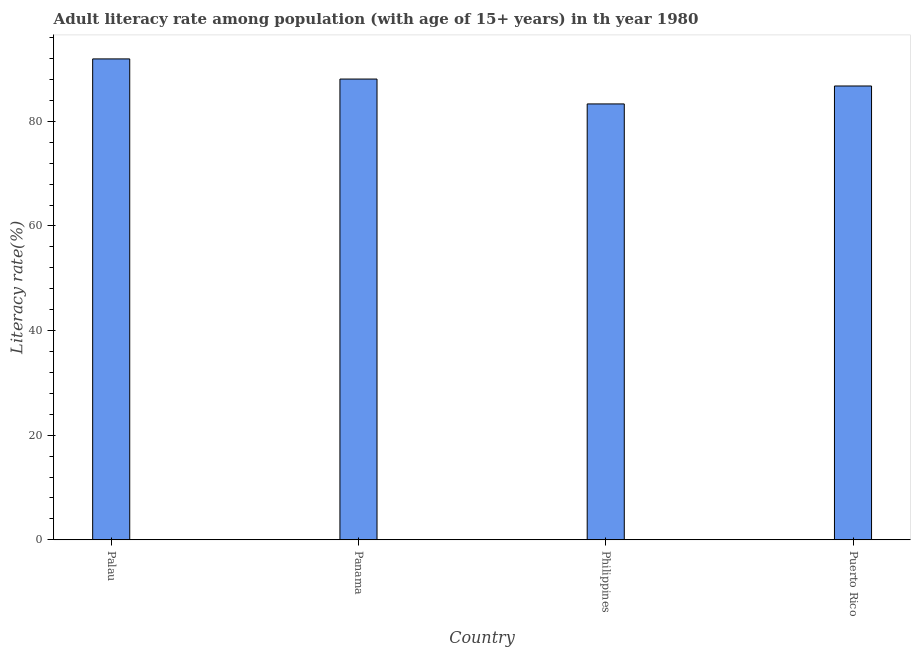Does the graph contain grids?
Offer a terse response. No. What is the title of the graph?
Make the answer very short. Adult literacy rate among population (with age of 15+ years) in th year 1980. What is the label or title of the Y-axis?
Your answer should be very brief. Literacy rate(%). What is the adult literacy rate in Philippines?
Your response must be concise. 83.32. Across all countries, what is the maximum adult literacy rate?
Provide a succinct answer. 91.92. Across all countries, what is the minimum adult literacy rate?
Give a very brief answer. 83.32. In which country was the adult literacy rate maximum?
Ensure brevity in your answer.  Palau. In which country was the adult literacy rate minimum?
Your response must be concise. Philippines. What is the sum of the adult literacy rate?
Your answer should be very brief. 350.06. What is the difference between the adult literacy rate in Palau and Puerto Rico?
Provide a succinct answer. 5.17. What is the average adult literacy rate per country?
Provide a short and direct response. 87.51. What is the median adult literacy rate?
Offer a terse response. 87.41. Is the difference between the adult literacy rate in Palau and Philippines greater than the difference between any two countries?
Your answer should be compact. Yes. What is the difference between the highest and the second highest adult literacy rate?
Make the answer very short. 3.85. Is the sum of the adult literacy rate in Palau and Philippines greater than the maximum adult literacy rate across all countries?
Give a very brief answer. Yes. What is the difference between the highest and the lowest adult literacy rate?
Your answer should be compact. 8.6. How many bars are there?
Provide a succinct answer. 4. Are all the bars in the graph horizontal?
Make the answer very short. No. Are the values on the major ticks of Y-axis written in scientific E-notation?
Your answer should be compact. No. What is the Literacy rate(%) in Palau?
Provide a short and direct response. 91.92. What is the Literacy rate(%) in Panama?
Your answer should be compact. 88.07. What is the Literacy rate(%) of Philippines?
Ensure brevity in your answer.  83.32. What is the Literacy rate(%) in Puerto Rico?
Make the answer very short. 86.75. What is the difference between the Literacy rate(%) in Palau and Panama?
Offer a terse response. 3.85. What is the difference between the Literacy rate(%) in Palau and Philippines?
Keep it short and to the point. 8.6. What is the difference between the Literacy rate(%) in Palau and Puerto Rico?
Ensure brevity in your answer.  5.18. What is the difference between the Literacy rate(%) in Panama and Philippines?
Provide a short and direct response. 4.75. What is the difference between the Literacy rate(%) in Panama and Puerto Rico?
Make the answer very short. 1.33. What is the difference between the Literacy rate(%) in Philippines and Puerto Rico?
Provide a short and direct response. -3.43. What is the ratio of the Literacy rate(%) in Palau to that in Panama?
Give a very brief answer. 1.04. What is the ratio of the Literacy rate(%) in Palau to that in Philippines?
Offer a terse response. 1.1. What is the ratio of the Literacy rate(%) in Palau to that in Puerto Rico?
Your answer should be very brief. 1.06. What is the ratio of the Literacy rate(%) in Panama to that in Philippines?
Your response must be concise. 1.06. What is the ratio of the Literacy rate(%) in Panama to that in Puerto Rico?
Your answer should be very brief. 1.01. What is the ratio of the Literacy rate(%) in Philippines to that in Puerto Rico?
Your answer should be compact. 0.96. 